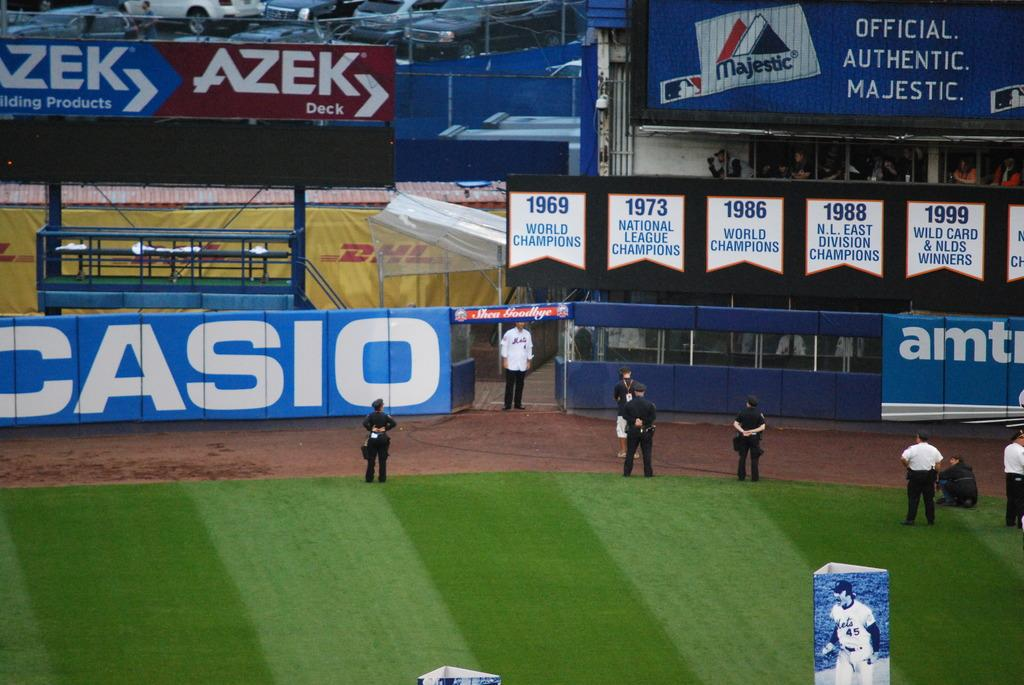<image>
Offer a succinct explanation of the picture presented. Police are gathered around the edge of a sports field with a large Casio sign on the fence. 